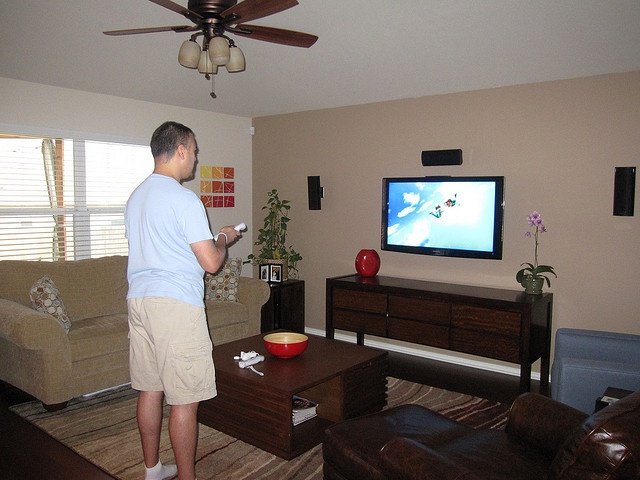Describe the objects in this image and their specific colors. I can see people in gray, lavender, darkgray, tan, and brown tones, couch in gray and black tones, chair in gray, black, and darkgray tones, tv in gray, white, black, and lightblue tones, and potted plant in gray, black, and darkgreen tones in this image. 